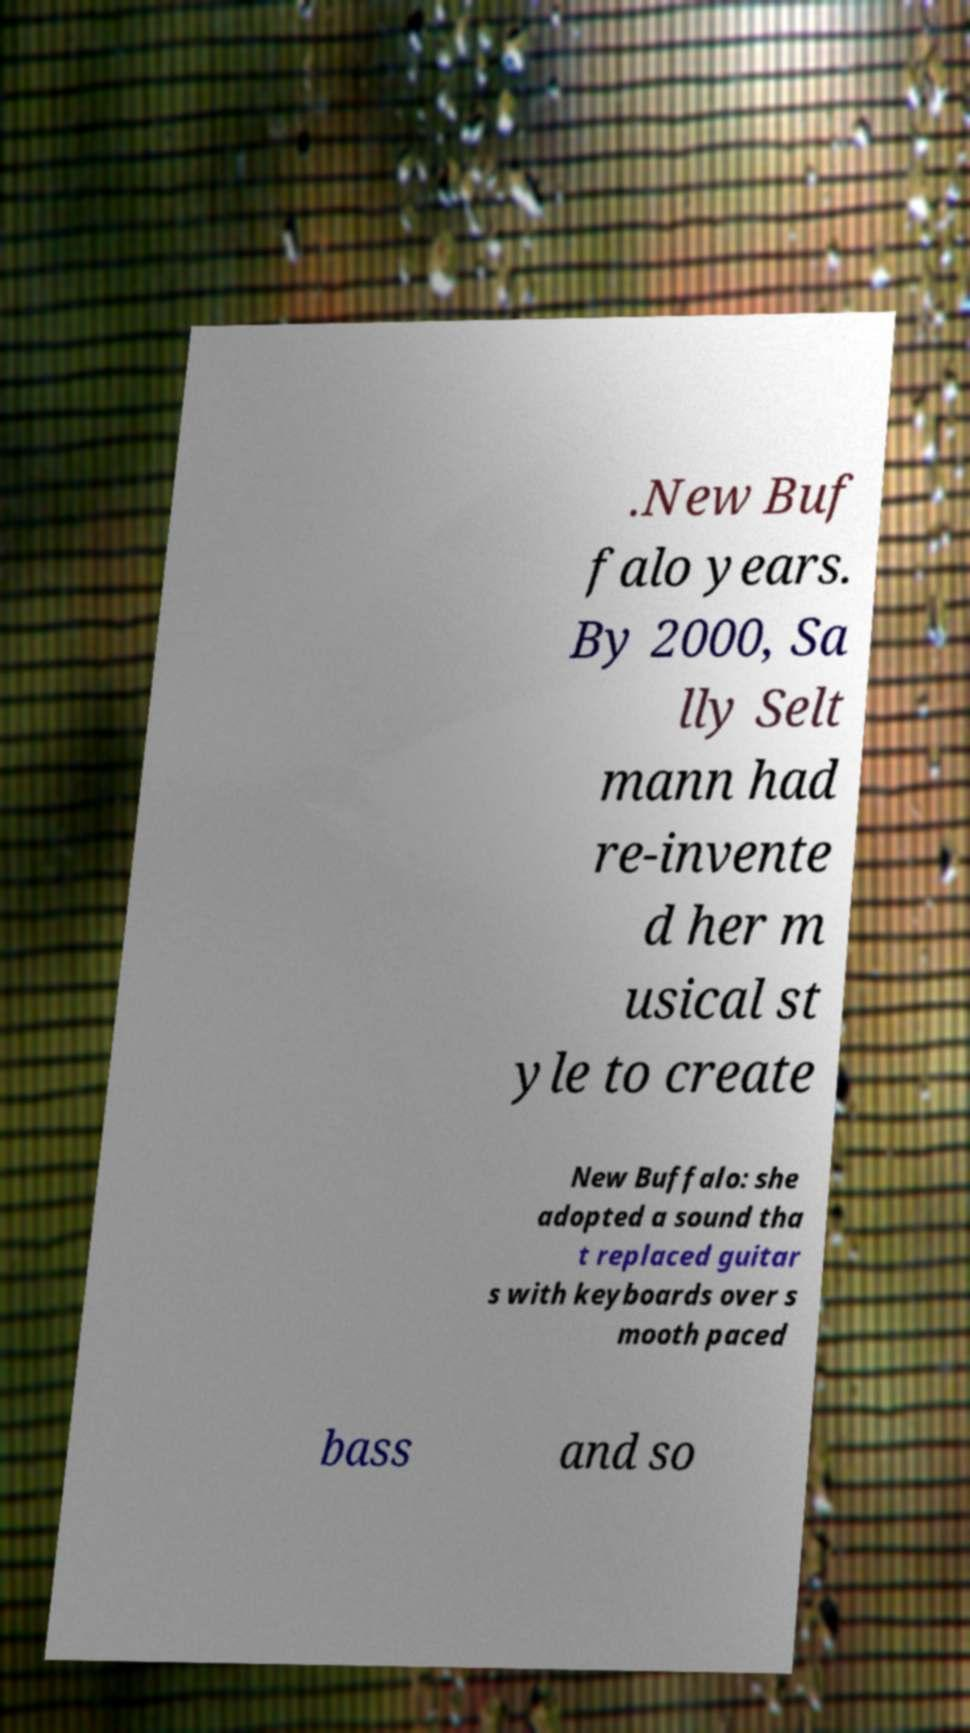Could you extract and type out the text from this image? .New Buf falo years. By 2000, Sa lly Selt mann had re-invente d her m usical st yle to create New Buffalo: she adopted a sound tha t replaced guitar s with keyboards over s mooth paced bass and so 